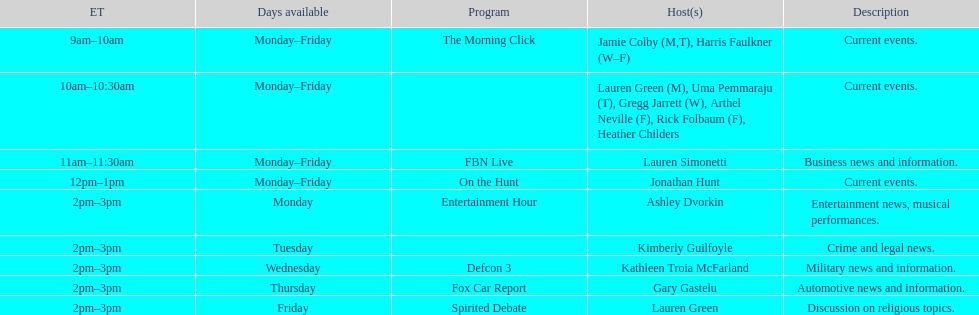What is the length of the defcon 3 program? 1 hour. 